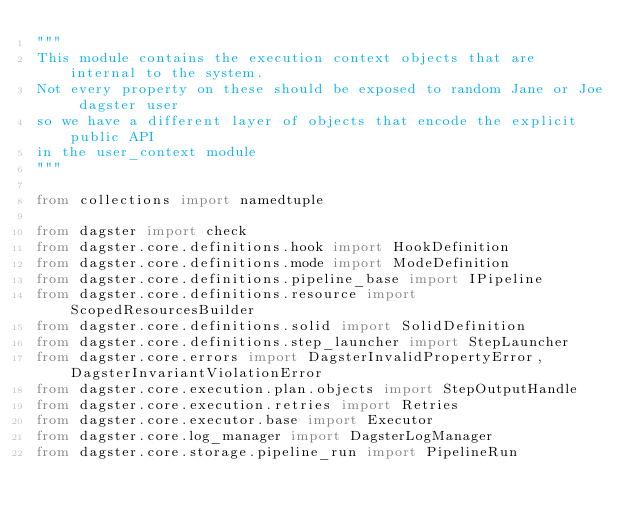<code> <loc_0><loc_0><loc_500><loc_500><_Python_>"""
This module contains the execution context objects that are internal to the system.
Not every property on these should be exposed to random Jane or Joe dagster user
so we have a different layer of objects that encode the explicit public API
in the user_context module
"""

from collections import namedtuple

from dagster import check
from dagster.core.definitions.hook import HookDefinition
from dagster.core.definitions.mode import ModeDefinition
from dagster.core.definitions.pipeline_base import IPipeline
from dagster.core.definitions.resource import ScopedResourcesBuilder
from dagster.core.definitions.solid import SolidDefinition
from dagster.core.definitions.step_launcher import StepLauncher
from dagster.core.errors import DagsterInvalidPropertyError, DagsterInvariantViolationError
from dagster.core.execution.plan.objects import StepOutputHandle
from dagster.core.execution.retries import Retries
from dagster.core.executor.base import Executor
from dagster.core.log_manager import DagsterLogManager
from dagster.core.storage.pipeline_run import PipelineRun</code> 